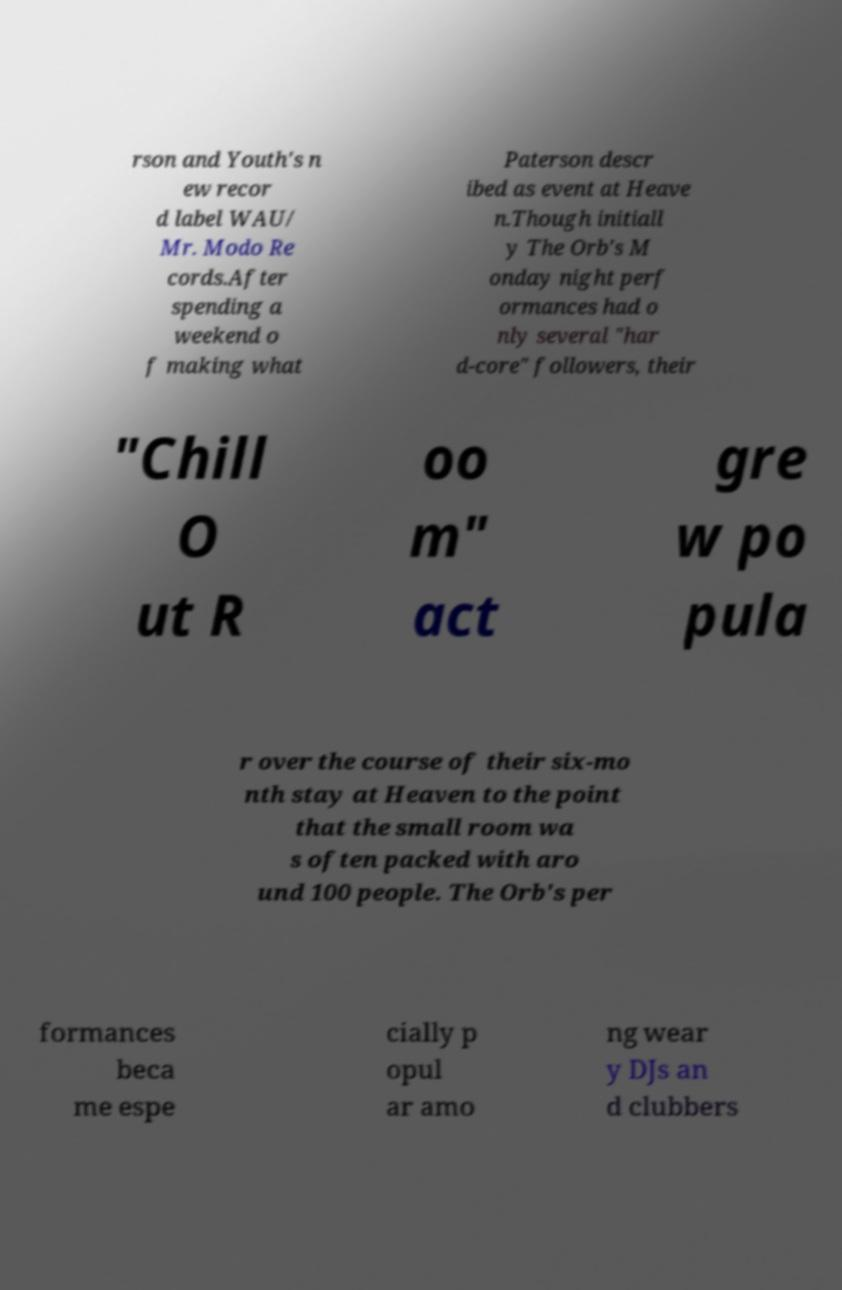What messages or text are displayed in this image? I need them in a readable, typed format. rson and Youth's n ew recor d label WAU/ Mr. Modo Re cords.After spending a weekend o f making what Paterson descr ibed as event at Heave n.Though initiall y The Orb's M onday night perf ormances had o nly several "har d-core" followers, their "Chill O ut R oo m" act gre w po pula r over the course of their six-mo nth stay at Heaven to the point that the small room wa s often packed with aro und 100 people. The Orb's per formances beca me espe cially p opul ar amo ng wear y DJs an d clubbers 